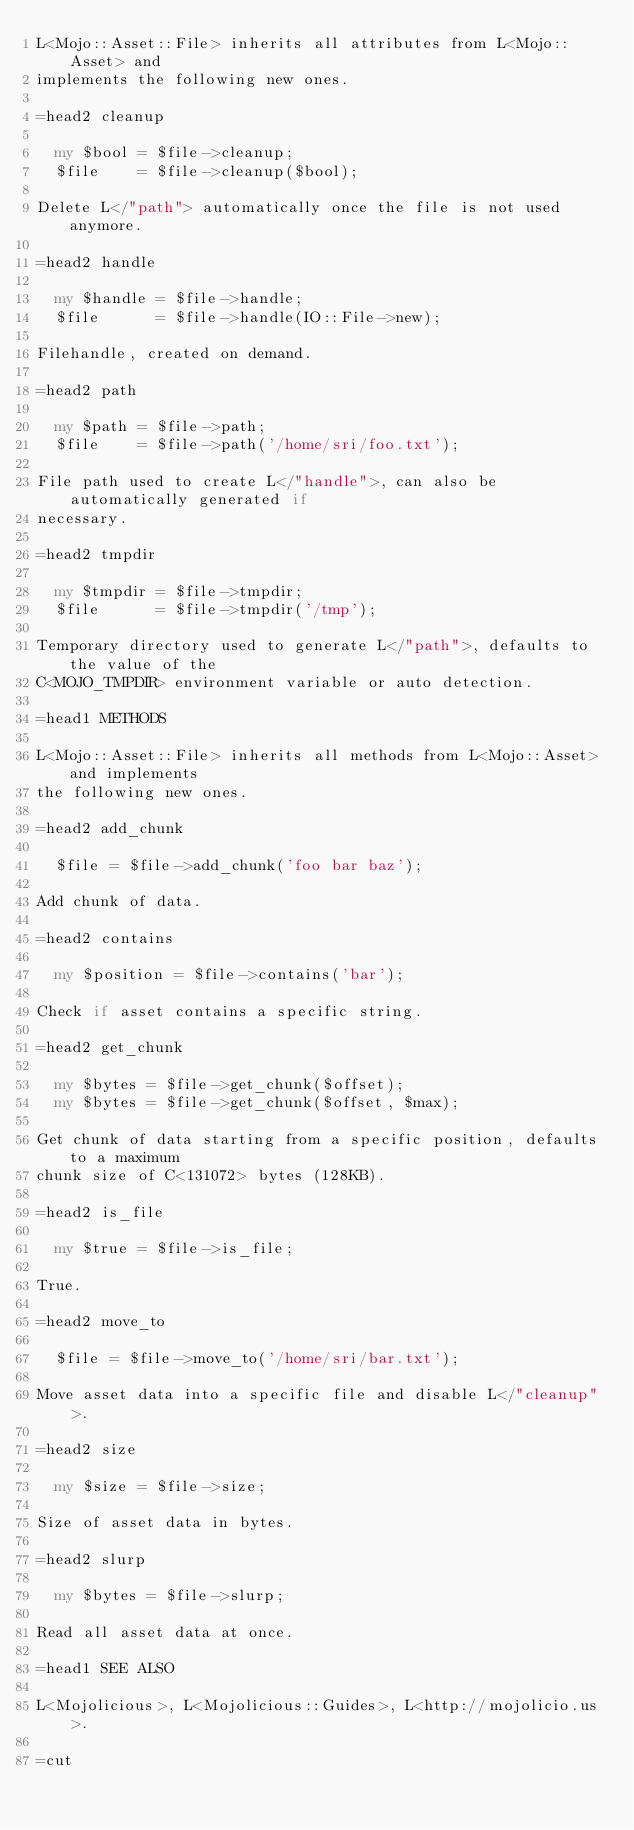Convert code to text. <code><loc_0><loc_0><loc_500><loc_500><_Perl_>L<Mojo::Asset::File> inherits all attributes from L<Mojo::Asset> and
implements the following new ones.

=head2 cleanup

  my $bool = $file->cleanup;
  $file    = $file->cleanup($bool);

Delete L</"path"> automatically once the file is not used anymore.

=head2 handle

  my $handle = $file->handle;
  $file      = $file->handle(IO::File->new);

Filehandle, created on demand.

=head2 path

  my $path = $file->path;
  $file    = $file->path('/home/sri/foo.txt');

File path used to create L</"handle">, can also be automatically generated if
necessary.

=head2 tmpdir

  my $tmpdir = $file->tmpdir;
  $file      = $file->tmpdir('/tmp');

Temporary directory used to generate L</"path">, defaults to the value of the
C<MOJO_TMPDIR> environment variable or auto detection.

=head1 METHODS

L<Mojo::Asset::File> inherits all methods from L<Mojo::Asset> and implements
the following new ones.

=head2 add_chunk

  $file = $file->add_chunk('foo bar baz');

Add chunk of data.

=head2 contains

  my $position = $file->contains('bar');

Check if asset contains a specific string.

=head2 get_chunk

  my $bytes = $file->get_chunk($offset);
  my $bytes = $file->get_chunk($offset, $max);

Get chunk of data starting from a specific position, defaults to a maximum
chunk size of C<131072> bytes (128KB).

=head2 is_file

  my $true = $file->is_file;

True.

=head2 move_to

  $file = $file->move_to('/home/sri/bar.txt');

Move asset data into a specific file and disable L</"cleanup">.

=head2 size

  my $size = $file->size;

Size of asset data in bytes.

=head2 slurp

  my $bytes = $file->slurp;

Read all asset data at once.

=head1 SEE ALSO

L<Mojolicious>, L<Mojolicious::Guides>, L<http://mojolicio.us>.

=cut
</code> 